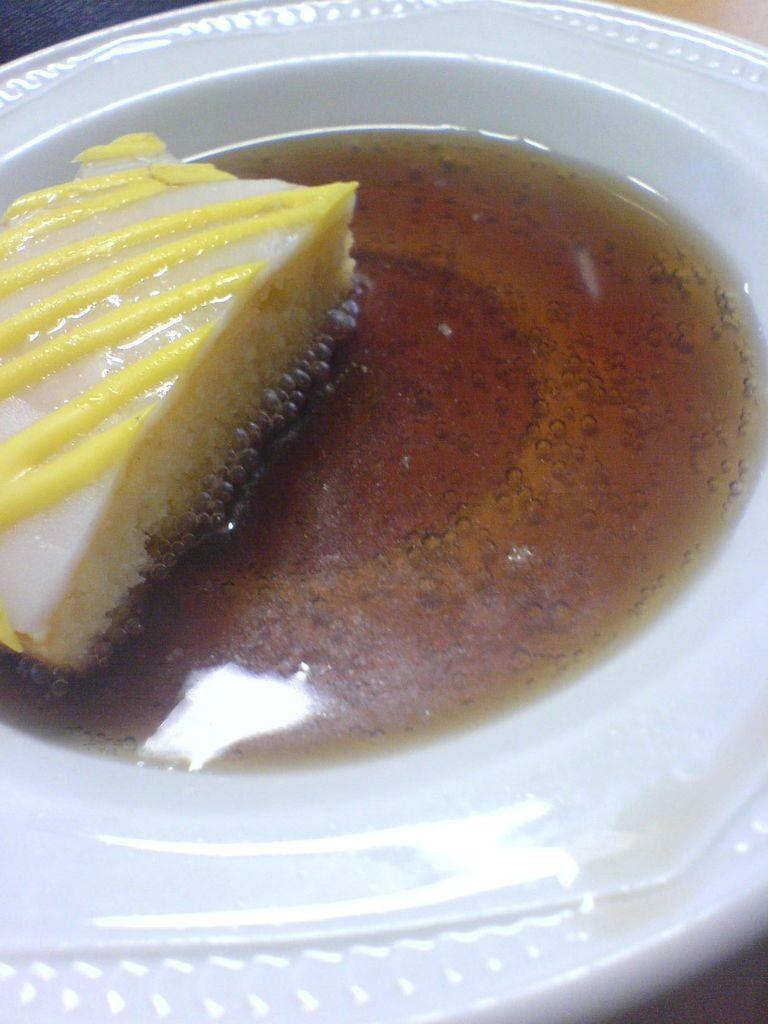What is on the plate in the image? There is a plate containing food in the image. Is there any dirt visible on the plate in the image? No, there is no dirt visible on the plate in the image. Can you see any icicles hanging from the plate in the image? No, there are no icicles present in the image. 